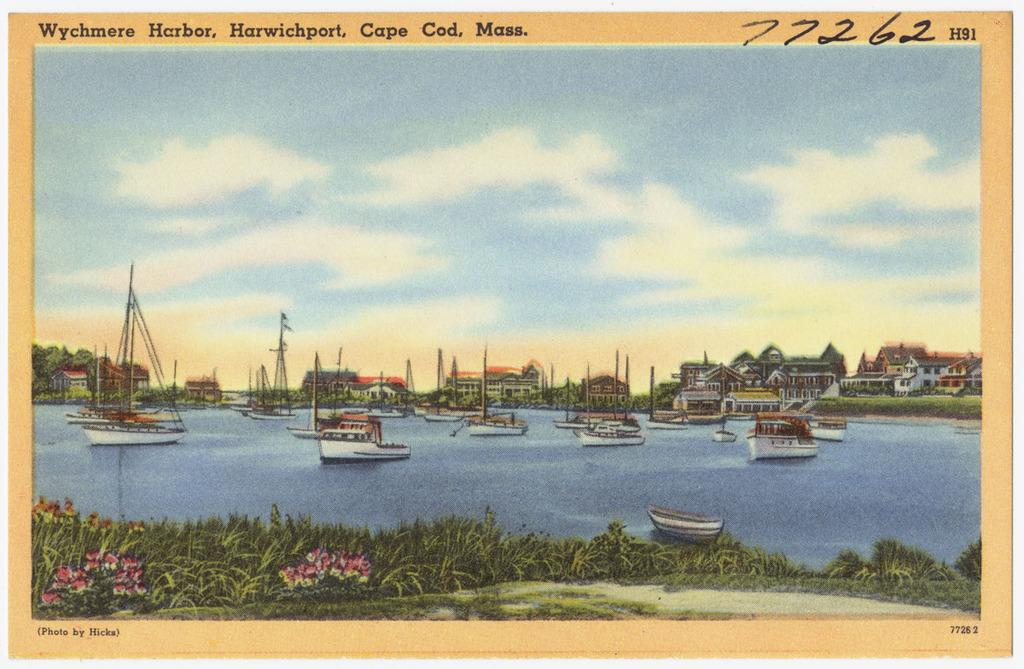Provide a one-sentence caption for the provided image. A painting of a bay full of boats in Cape Code, Mass. 